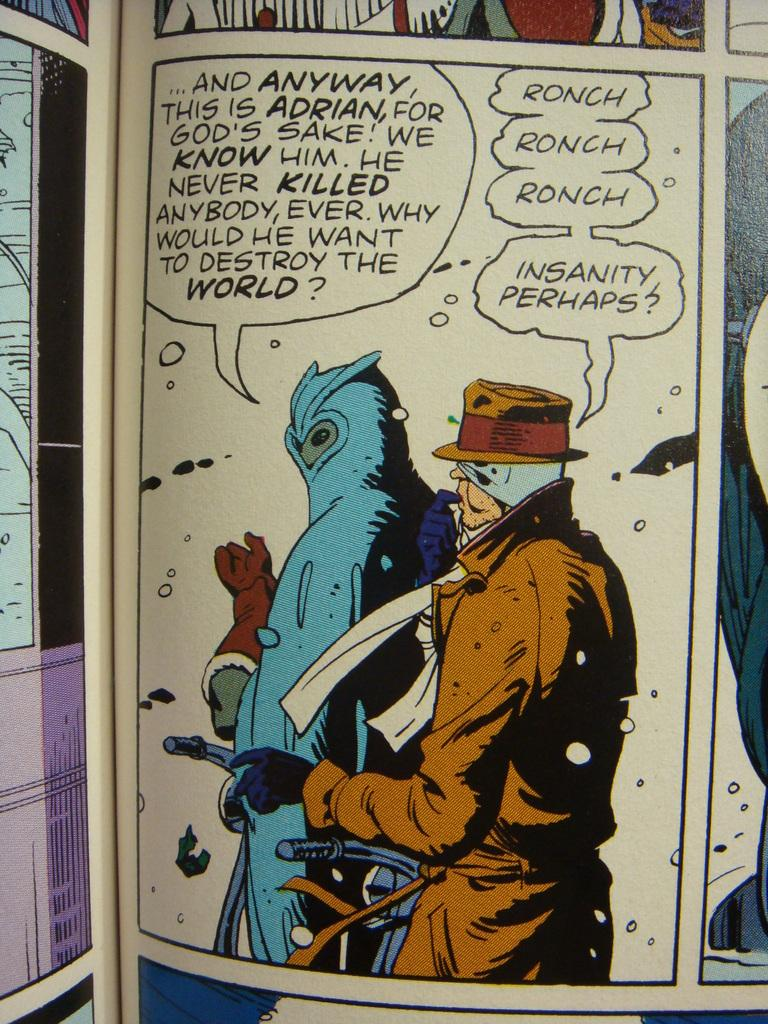What type of images can be seen on the papers in the image? There are cartoon images on the papers. What else can be found on the papers besides the images? There is writing on the paper. What is the weight of the cartoon images on the papers? The weight of the cartoon images cannot be determined from the image, as they are two-dimensional representations and do not have a measurable weight. 